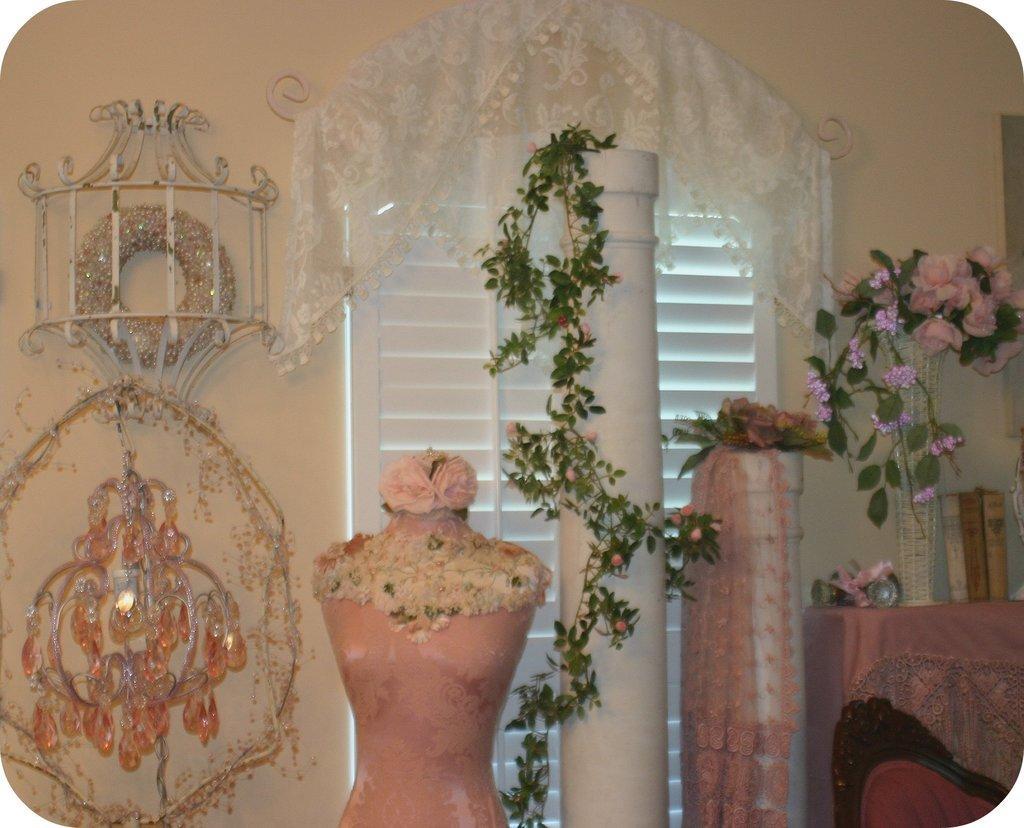How would you summarize this image in a sentence or two? In this picture I can observe mannequin. On the right side I can observe white color pillar. I can observe some plants. There is a chair on the right side. I can observe flower vase placed on the desk. In the background there is a window and a wall. 